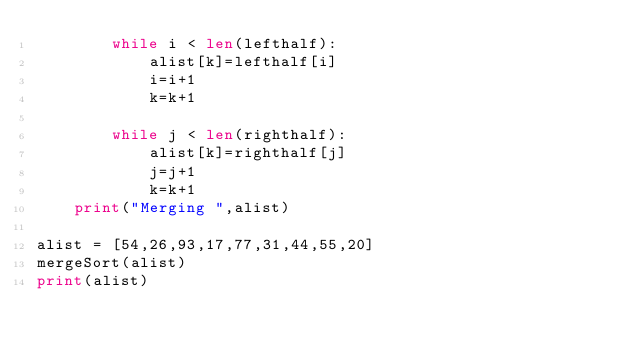<code> <loc_0><loc_0><loc_500><loc_500><_Python_>        while i < len(lefthalf):
            alist[k]=lefthalf[i]
            i=i+1
            k=k+1

        while j < len(righthalf):
            alist[k]=righthalf[j]
            j=j+1
            k=k+1
    print("Merging ",alist)

alist = [54,26,93,17,77,31,44,55,20]
mergeSort(alist)
print(alist)

</code> 